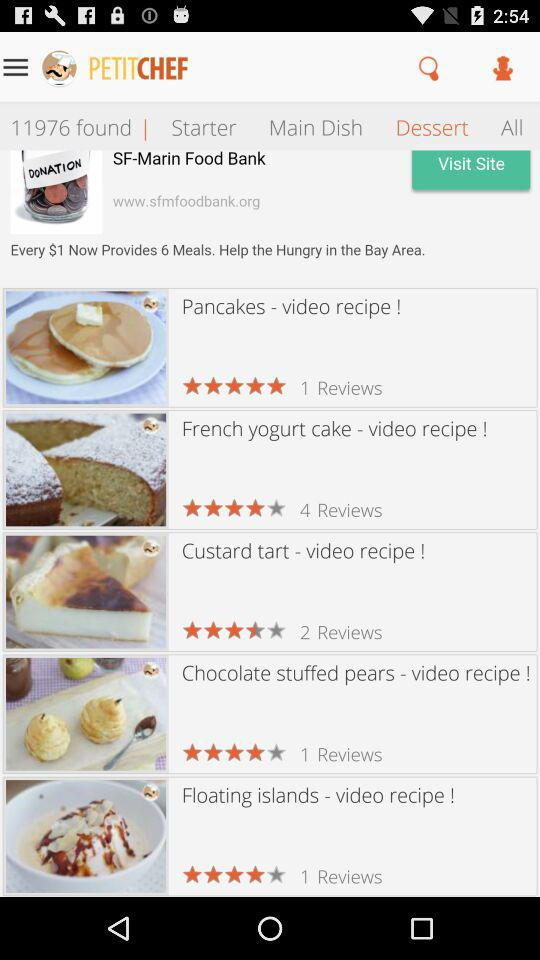What is the name of the application? The name of the application is "PETITCHEF". 